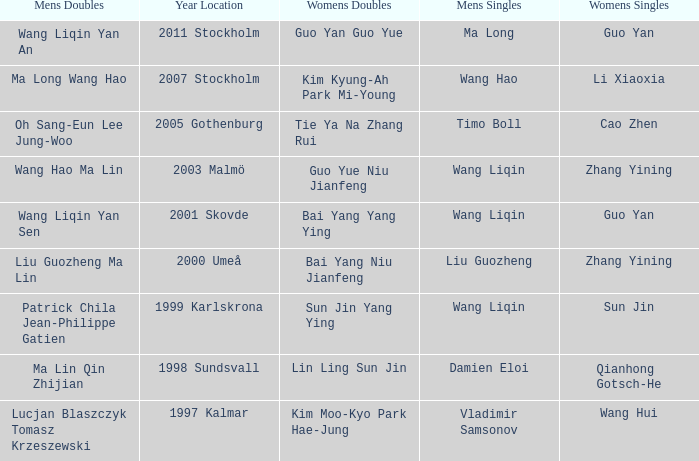How many times has Sun Jin won the women's doubles? 1.0. 